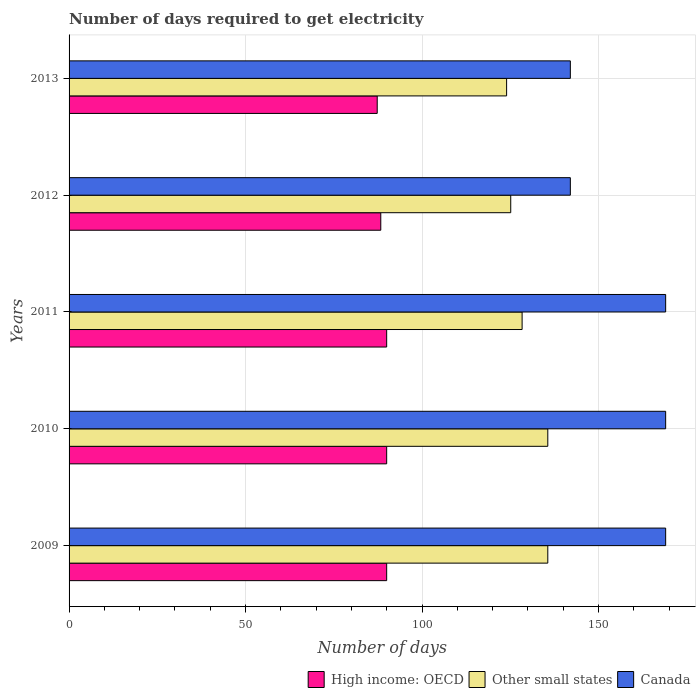Are the number of bars per tick equal to the number of legend labels?
Your answer should be very brief. Yes. Are the number of bars on each tick of the Y-axis equal?
Provide a succinct answer. Yes. What is the label of the 1st group of bars from the top?
Your answer should be compact. 2013. In how many cases, is the number of bars for a given year not equal to the number of legend labels?
Offer a very short reply. 0. What is the number of days required to get electricity in in Canada in 2013?
Provide a succinct answer. 142. Across all years, what is the maximum number of days required to get electricity in in Other small states?
Keep it short and to the point. 135.61. Across all years, what is the minimum number of days required to get electricity in in High income: OECD?
Make the answer very short. 87.29. In which year was the number of days required to get electricity in in Other small states maximum?
Offer a terse response. 2009. What is the total number of days required to get electricity in in High income: OECD in the graph?
Keep it short and to the point. 445.49. What is the difference between the number of days required to get electricity in in Other small states in 2010 and the number of days required to get electricity in in High income: OECD in 2013?
Your answer should be very brief. 48.32. What is the average number of days required to get electricity in in High income: OECD per year?
Provide a short and direct response. 89.1. In the year 2010, what is the difference between the number of days required to get electricity in in Canada and number of days required to get electricity in in High income: OECD?
Your answer should be very brief. 79.03. What is the ratio of the number of days required to get electricity in in High income: OECD in 2009 to that in 2013?
Your answer should be compact. 1.03. Is the difference between the number of days required to get electricity in in Canada in 2010 and 2012 greater than the difference between the number of days required to get electricity in in High income: OECD in 2010 and 2012?
Make the answer very short. Yes. What is the difference between the highest and the lowest number of days required to get electricity in in Canada?
Make the answer very short. 27. In how many years, is the number of days required to get electricity in in Canada greater than the average number of days required to get electricity in in Canada taken over all years?
Provide a succinct answer. 3. Is the sum of the number of days required to get electricity in in High income: OECD in 2011 and 2013 greater than the maximum number of days required to get electricity in in Canada across all years?
Your answer should be compact. Yes. What does the 1st bar from the top in 2012 represents?
Ensure brevity in your answer.  Canada. What does the 2nd bar from the bottom in 2012 represents?
Ensure brevity in your answer.  Other small states. Is it the case that in every year, the sum of the number of days required to get electricity in in Canada and number of days required to get electricity in in High income: OECD is greater than the number of days required to get electricity in in Other small states?
Your response must be concise. Yes. Are all the bars in the graph horizontal?
Offer a terse response. Yes. How many years are there in the graph?
Keep it short and to the point. 5. Are the values on the major ticks of X-axis written in scientific E-notation?
Give a very brief answer. No. Does the graph contain any zero values?
Provide a short and direct response. No. Does the graph contain grids?
Your response must be concise. Yes. Where does the legend appear in the graph?
Keep it short and to the point. Bottom right. What is the title of the graph?
Offer a terse response. Number of days required to get electricity. Does "Kosovo" appear as one of the legend labels in the graph?
Make the answer very short. No. What is the label or title of the X-axis?
Offer a very short reply. Number of days. What is the label or title of the Y-axis?
Give a very brief answer. Years. What is the Number of days in High income: OECD in 2009?
Give a very brief answer. 89.97. What is the Number of days in Other small states in 2009?
Provide a succinct answer. 135.61. What is the Number of days in Canada in 2009?
Keep it short and to the point. 169. What is the Number of days of High income: OECD in 2010?
Provide a short and direct response. 89.97. What is the Number of days in Other small states in 2010?
Offer a terse response. 135.61. What is the Number of days in Canada in 2010?
Make the answer very short. 169. What is the Number of days of High income: OECD in 2011?
Offer a very short reply. 89.97. What is the Number of days in Other small states in 2011?
Provide a short and direct response. 128.33. What is the Number of days of Canada in 2011?
Give a very brief answer. 169. What is the Number of days of High income: OECD in 2012?
Keep it short and to the point. 88.3. What is the Number of days in Other small states in 2012?
Offer a terse response. 125.11. What is the Number of days in Canada in 2012?
Offer a terse response. 142. What is the Number of days of High income: OECD in 2013?
Offer a terse response. 87.29. What is the Number of days in Other small states in 2013?
Keep it short and to the point. 123.94. What is the Number of days of Canada in 2013?
Keep it short and to the point. 142. Across all years, what is the maximum Number of days of High income: OECD?
Give a very brief answer. 89.97. Across all years, what is the maximum Number of days of Other small states?
Give a very brief answer. 135.61. Across all years, what is the maximum Number of days in Canada?
Your answer should be very brief. 169. Across all years, what is the minimum Number of days in High income: OECD?
Offer a very short reply. 87.29. Across all years, what is the minimum Number of days of Other small states?
Provide a short and direct response. 123.94. Across all years, what is the minimum Number of days of Canada?
Give a very brief answer. 142. What is the total Number of days in High income: OECD in the graph?
Provide a succinct answer. 445.49. What is the total Number of days in Other small states in the graph?
Your answer should be compact. 648.61. What is the total Number of days of Canada in the graph?
Your answer should be compact. 791. What is the difference between the Number of days of Canada in 2009 and that in 2010?
Ensure brevity in your answer.  0. What is the difference between the Number of days in Other small states in 2009 and that in 2011?
Offer a terse response. 7.28. What is the difference between the Number of days of Canada in 2009 and that in 2011?
Give a very brief answer. 0. What is the difference between the Number of days of High income: OECD in 2009 and that in 2013?
Keep it short and to the point. 2.68. What is the difference between the Number of days of Other small states in 2009 and that in 2013?
Offer a very short reply. 11.67. What is the difference between the Number of days of Canada in 2009 and that in 2013?
Provide a short and direct response. 27. What is the difference between the Number of days in Other small states in 2010 and that in 2011?
Your answer should be compact. 7.28. What is the difference between the Number of days in Canada in 2010 and that in 2011?
Provide a succinct answer. 0. What is the difference between the Number of days of Other small states in 2010 and that in 2012?
Your answer should be very brief. 10.5. What is the difference between the Number of days of Canada in 2010 and that in 2012?
Your answer should be very brief. 27. What is the difference between the Number of days in High income: OECD in 2010 and that in 2013?
Provide a succinct answer. 2.68. What is the difference between the Number of days in Other small states in 2010 and that in 2013?
Ensure brevity in your answer.  11.67. What is the difference between the Number of days of Other small states in 2011 and that in 2012?
Keep it short and to the point. 3.22. What is the difference between the Number of days in Canada in 2011 and that in 2012?
Give a very brief answer. 27. What is the difference between the Number of days of High income: OECD in 2011 and that in 2013?
Make the answer very short. 2.68. What is the difference between the Number of days of Other small states in 2011 and that in 2013?
Offer a very short reply. 4.39. What is the difference between the Number of days in Canada in 2011 and that in 2013?
Provide a short and direct response. 27. What is the difference between the Number of days of High income: OECD in 2012 and that in 2013?
Your answer should be compact. 1.01. What is the difference between the Number of days in High income: OECD in 2009 and the Number of days in Other small states in 2010?
Offer a terse response. -45.64. What is the difference between the Number of days in High income: OECD in 2009 and the Number of days in Canada in 2010?
Your answer should be very brief. -79.03. What is the difference between the Number of days of Other small states in 2009 and the Number of days of Canada in 2010?
Your response must be concise. -33.39. What is the difference between the Number of days in High income: OECD in 2009 and the Number of days in Other small states in 2011?
Your response must be concise. -38.37. What is the difference between the Number of days of High income: OECD in 2009 and the Number of days of Canada in 2011?
Ensure brevity in your answer.  -79.03. What is the difference between the Number of days of Other small states in 2009 and the Number of days of Canada in 2011?
Give a very brief answer. -33.39. What is the difference between the Number of days in High income: OECD in 2009 and the Number of days in Other small states in 2012?
Ensure brevity in your answer.  -35.14. What is the difference between the Number of days of High income: OECD in 2009 and the Number of days of Canada in 2012?
Make the answer very short. -52.03. What is the difference between the Number of days of Other small states in 2009 and the Number of days of Canada in 2012?
Provide a succinct answer. -6.39. What is the difference between the Number of days of High income: OECD in 2009 and the Number of days of Other small states in 2013?
Keep it short and to the point. -33.98. What is the difference between the Number of days in High income: OECD in 2009 and the Number of days in Canada in 2013?
Provide a succinct answer. -52.03. What is the difference between the Number of days in Other small states in 2009 and the Number of days in Canada in 2013?
Provide a short and direct response. -6.39. What is the difference between the Number of days in High income: OECD in 2010 and the Number of days in Other small states in 2011?
Provide a short and direct response. -38.37. What is the difference between the Number of days of High income: OECD in 2010 and the Number of days of Canada in 2011?
Offer a terse response. -79.03. What is the difference between the Number of days in Other small states in 2010 and the Number of days in Canada in 2011?
Ensure brevity in your answer.  -33.39. What is the difference between the Number of days in High income: OECD in 2010 and the Number of days in Other small states in 2012?
Give a very brief answer. -35.14. What is the difference between the Number of days in High income: OECD in 2010 and the Number of days in Canada in 2012?
Provide a short and direct response. -52.03. What is the difference between the Number of days of Other small states in 2010 and the Number of days of Canada in 2012?
Offer a very short reply. -6.39. What is the difference between the Number of days of High income: OECD in 2010 and the Number of days of Other small states in 2013?
Your answer should be very brief. -33.98. What is the difference between the Number of days in High income: OECD in 2010 and the Number of days in Canada in 2013?
Provide a short and direct response. -52.03. What is the difference between the Number of days in Other small states in 2010 and the Number of days in Canada in 2013?
Your answer should be compact. -6.39. What is the difference between the Number of days in High income: OECD in 2011 and the Number of days in Other small states in 2012?
Give a very brief answer. -35.14. What is the difference between the Number of days of High income: OECD in 2011 and the Number of days of Canada in 2012?
Ensure brevity in your answer.  -52.03. What is the difference between the Number of days in Other small states in 2011 and the Number of days in Canada in 2012?
Provide a short and direct response. -13.67. What is the difference between the Number of days in High income: OECD in 2011 and the Number of days in Other small states in 2013?
Your answer should be very brief. -33.98. What is the difference between the Number of days of High income: OECD in 2011 and the Number of days of Canada in 2013?
Give a very brief answer. -52.03. What is the difference between the Number of days in Other small states in 2011 and the Number of days in Canada in 2013?
Your response must be concise. -13.67. What is the difference between the Number of days of High income: OECD in 2012 and the Number of days of Other small states in 2013?
Offer a terse response. -35.64. What is the difference between the Number of days in High income: OECD in 2012 and the Number of days in Canada in 2013?
Keep it short and to the point. -53.7. What is the difference between the Number of days of Other small states in 2012 and the Number of days of Canada in 2013?
Make the answer very short. -16.89. What is the average Number of days in High income: OECD per year?
Offer a very short reply. 89.1. What is the average Number of days of Other small states per year?
Your response must be concise. 129.72. What is the average Number of days of Canada per year?
Make the answer very short. 158.2. In the year 2009, what is the difference between the Number of days of High income: OECD and Number of days of Other small states?
Provide a short and direct response. -45.64. In the year 2009, what is the difference between the Number of days in High income: OECD and Number of days in Canada?
Keep it short and to the point. -79.03. In the year 2009, what is the difference between the Number of days of Other small states and Number of days of Canada?
Offer a very short reply. -33.39. In the year 2010, what is the difference between the Number of days of High income: OECD and Number of days of Other small states?
Provide a short and direct response. -45.64. In the year 2010, what is the difference between the Number of days of High income: OECD and Number of days of Canada?
Your answer should be very brief. -79.03. In the year 2010, what is the difference between the Number of days in Other small states and Number of days in Canada?
Your answer should be very brief. -33.39. In the year 2011, what is the difference between the Number of days in High income: OECD and Number of days in Other small states?
Make the answer very short. -38.37. In the year 2011, what is the difference between the Number of days of High income: OECD and Number of days of Canada?
Your answer should be compact. -79.03. In the year 2011, what is the difference between the Number of days of Other small states and Number of days of Canada?
Offer a very short reply. -40.67. In the year 2012, what is the difference between the Number of days of High income: OECD and Number of days of Other small states?
Keep it short and to the point. -36.81. In the year 2012, what is the difference between the Number of days in High income: OECD and Number of days in Canada?
Provide a short and direct response. -53.7. In the year 2012, what is the difference between the Number of days in Other small states and Number of days in Canada?
Ensure brevity in your answer.  -16.89. In the year 2013, what is the difference between the Number of days in High income: OECD and Number of days in Other small states?
Your answer should be compact. -36.65. In the year 2013, what is the difference between the Number of days in High income: OECD and Number of days in Canada?
Make the answer very short. -54.71. In the year 2013, what is the difference between the Number of days of Other small states and Number of days of Canada?
Your response must be concise. -18.06. What is the ratio of the Number of days in High income: OECD in 2009 to that in 2010?
Your response must be concise. 1. What is the ratio of the Number of days of Canada in 2009 to that in 2010?
Keep it short and to the point. 1. What is the ratio of the Number of days of High income: OECD in 2009 to that in 2011?
Your response must be concise. 1. What is the ratio of the Number of days of Other small states in 2009 to that in 2011?
Give a very brief answer. 1.06. What is the ratio of the Number of days in High income: OECD in 2009 to that in 2012?
Keep it short and to the point. 1.02. What is the ratio of the Number of days in Other small states in 2009 to that in 2012?
Keep it short and to the point. 1.08. What is the ratio of the Number of days in Canada in 2009 to that in 2012?
Keep it short and to the point. 1.19. What is the ratio of the Number of days of High income: OECD in 2009 to that in 2013?
Offer a terse response. 1.03. What is the ratio of the Number of days of Other small states in 2009 to that in 2013?
Ensure brevity in your answer.  1.09. What is the ratio of the Number of days of Canada in 2009 to that in 2013?
Provide a succinct answer. 1.19. What is the ratio of the Number of days of Other small states in 2010 to that in 2011?
Make the answer very short. 1.06. What is the ratio of the Number of days in Canada in 2010 to that in 2011?
Provide a short and direct response. 1. What is the ratio of the Number of days in High income: OECD in 2010 to that in 2012?
Give a very brief answer. 1.02. What is the ratio of the Number of days in Other small states in 2010 to that in 2012?
Ensure brevity in your answer.  1.08. What is the ratio of the Number of days in Canada in 2010 to that in 2012?
Offer a terse response. 1.19. What is the ratio of the Number of days in High income: OECD in 2010 to that in 2013?
Provide a succinct answer. 1.03. What is the ratio of the Number of days of Other small states in 2010 to that in 2013?
Ensure brevity in your answer.  1.09. What is the ratio of the Number of days of Canada in 2010 to that in 2013?
Your response must be concise. 1.19. What is the ratio of the Number of days of High income: OECD in 2011 to that in 2012?
Your response must be concise. 1.02. What is the ratio of the Number of days in Other small states in 2011 to that in 2012?
Make the answer very short. 1.03. What is the ratio of the Number of days of Canada in 2011 to that in 2012?
Provide a succinct answer. 1.19. What is the ratio of the Number of days in High income: OECD in 2011 to that in 2013?
Offer a terse response. 1.03. What is the ratio of the Number of days in Other small states in 2011 to that in 2013?
Provide a short and direct response. 1.04. What is the ratio of the Number of days in Canada in 2011 to that in 2013?
Give a very brief answer. 1.19. What is the ratio of the Number of days of High income: OECD in 2012 to that in 2013?
Make the answer very short. 1.01. What is the ratio of the Number of days in Other small states in 2012 to that in 2013?
Give a very brief answer. 1.01. What is the difference between the highest and the second highest Number of days in Other small states?
Ensure brevity in your answer.  0. What is the difference between the highest and the second highest Number of days of Canada?
Offer a very short reply. 0. What is the difference between the highest and the lowest Number of days of High income: OECD?
Your answer should be very brief. 2.68. What is the difference between the highest and the lowest Number of days of Other small states?
Your response must be concise. 11.67. What is the difference between the highest and the lowest Number of days in Canada?
Your response must be concise. 27. 